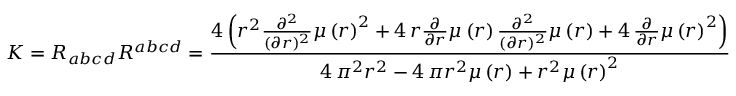<formula> <loc_0><loc_0><loc_500><loc_500>K = R _ { a b c d } R ^ { a b c d } = \frac { 4 \, { \left ( r ^ { 2 } \frac { \partial ^ { 2 } } { ( \partial r ) ^ { 2 } } \mu \left ( r \right ) ^ { 2 } + 4 \, r \frac { \partial } { \partial r } \mu \left ( r \right ) \frac { \partial ^ { 2 } } { ( \partial r ) ^ { 2 } } \mu \left ( r \right ) + 4 \, \frac { \partial } { \partial r } \mu \left ( r \right ) ^ { 2 } \right ) } } { 4 \, \pi ^ { 2 } r ^ { 2 } - 4 \, \pi r ^ { 2 } \mu \left ( r \right ) + r ^ { 2 } \mu \left ( r \right ) ^ { 2 } }</formula> 